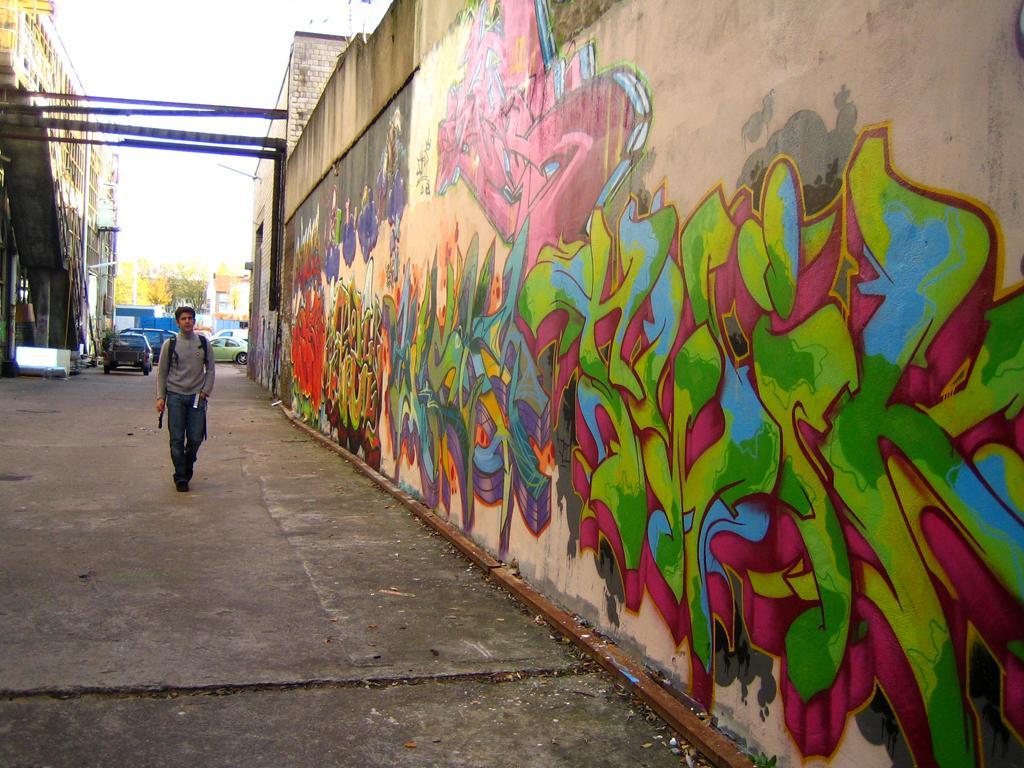How would you summarize this image in a sentence or two? This image is clicked on the road. There is a man walking on the road. Behind him there are vehicles on the road. On the either sides of the road there are houses. To the right there is a wall of a house. There is a graffiti art on the wall. In the background there are trees. At the top there is the sky. 